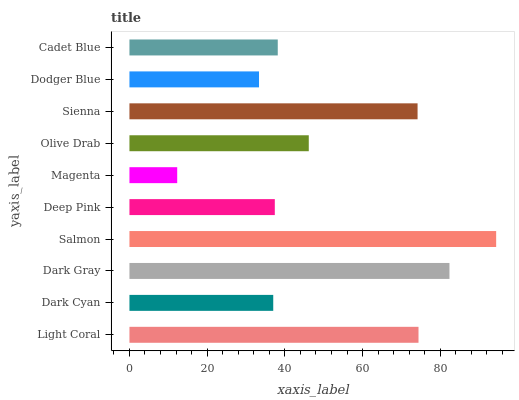Is Magenta the minimum?
Answer yes or no. Yes. Is Salmon the maximum?
Answer yes or no. Yes. Is Dark Cyan the minimum?
Answer yes or no. No. Is Dark Cyan the maximum?
Answer yes or no. No. Is Light Coral greater than Dark Cyan?
Answer yes or no. Yes. Is Dark Cyan less than Light Coral?
Answer yes or no. Yes. Is Dark Cyan greater than Light Coral?
Answer yes or no. No. Is Light Coral less than Dark Cyan?
Answer yes or no. No. Is Olive Drab the high median?
Answer yes or no. Yes. Is Cadet Blue the low median?
Answer yes or no. Yes. Is Light Coral the high median?
Answer yes or no. No. Is Dark Cyan the low median?
Answer yes or no. No. 